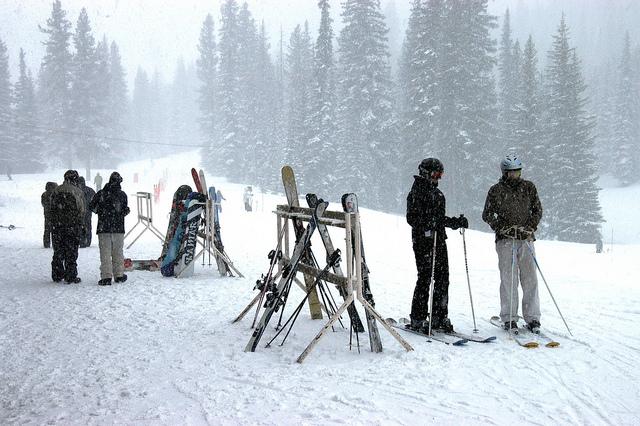Is this considered a white-out?
Answer briefly. No. How many people in the shot?
Keep it brief. 5. What is the weather like?
Quick response, please. Snowy. 